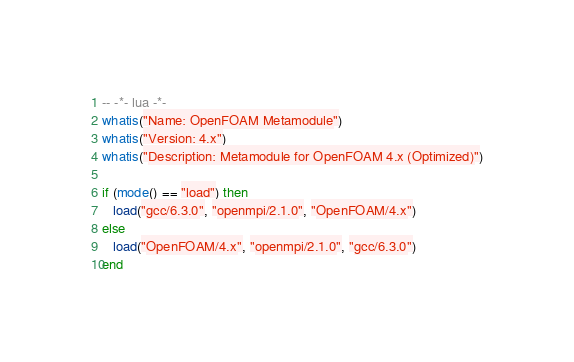<code> <loc_0><loc_0><loc_500><loc_500><_Lua_>-- -*- lua -*-
whatis("Name: OpenFOAM Metamodule")
whatis("Version: 4.x")
whatis("Description: Metamodule for OpenFOAM 4.x (Optimized)")

if (mode() == "load") then
   load("gcc/6.3.0", "openmpi/2.1.0", "OpenFOAM/4.x")
else
   load("OpenFOAM/4.x", "openmpi/2.1.0", "gcc/6.3.0")
end
</code> 